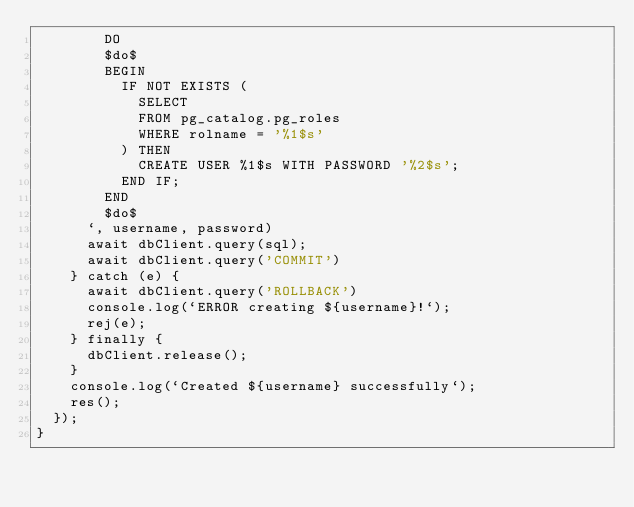<code> <loc_0><loc_0><loc_500><loc_500><_JavaScript_>        DO
        $do$
        BEGIN
          IF NOT EXISTS (
            SELECT
            FROM pg_catalog.pg_roles
            WHERE rolname = '%1$s'
          ) THEN
            CREATE USER %1$s WITH PASSWORD '%2$s';
          END IF;
        END
        $do$
      `, username, password)
      await dbClient.query(sql);
      await dbClient.query('COMMIT')
    } catch (e) {
      await dbClient.query('ROLLBACK')
      console.log(`ERROR creating ${username}!`);
      rej(e);
    } finally {
      dbClient.release();
    }
    console.log(`Created ${username} successfully`);
    res();
  });
}</code> 